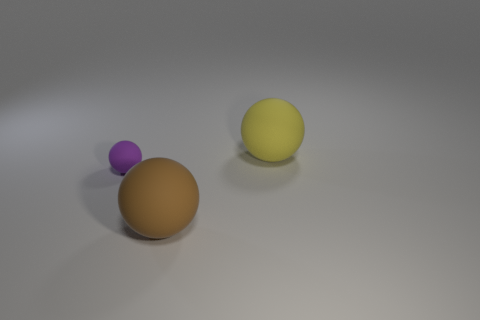Subtract all purple matte spheres. How many spheres are left? 2 Add 2 large red objects. How many objects exist? 5 Add 2 brown spheres. How many brown spheres are left? 3 Add 1 gray metal things. How many gray metal things exist? 1 Subtract 0 blue spheres. How many objects are left? 3 Subtract all rubber things. Subtract all blue metal balls. How many objects are left? 0 